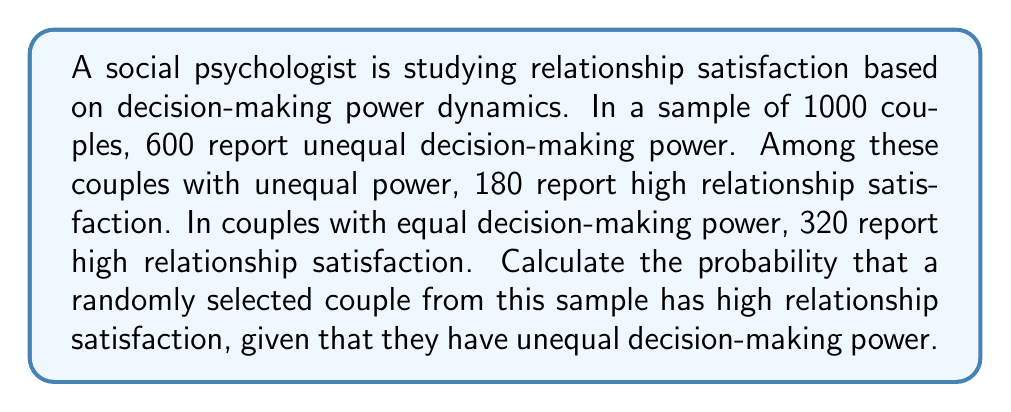Help me with this question. To solve this problem, we'll use Bayes' theorem, which is given by:

$$P(A|B) = \frac{P(B|A) \cdot P(A)}{P(B)}$$

Where:
$A$ = high relationship satisfaction
$B$ = unequal decision-making power

Let's calculate each component:

1. $P(B|A)$: Probability of unequal power given high satisfaction
   Total high satisfaction: $180 + 320 = 500$
   $P(B|A) = \frac{180}{500} = 0.36$

2. $P(A)$: Probability of high satisfaction
   $P(A) = \frac{500}{1000} = 0.5$

3. $P(B)$: Probability of unequal power
   $P(B) = \frac{600}{1000} = 0.6$

Now, we can apply Bayes' theorem:

$$P(A|B) = \frac{0.36 \cdot 0.5}{0.6} = \frac{0.18}{0.6} = 0.3$$

Therefore, the probability of high relationship satisfaction given unequal decision-making power is 0.3 or 30%.
Answer: $0.3$ or $30\%$ 